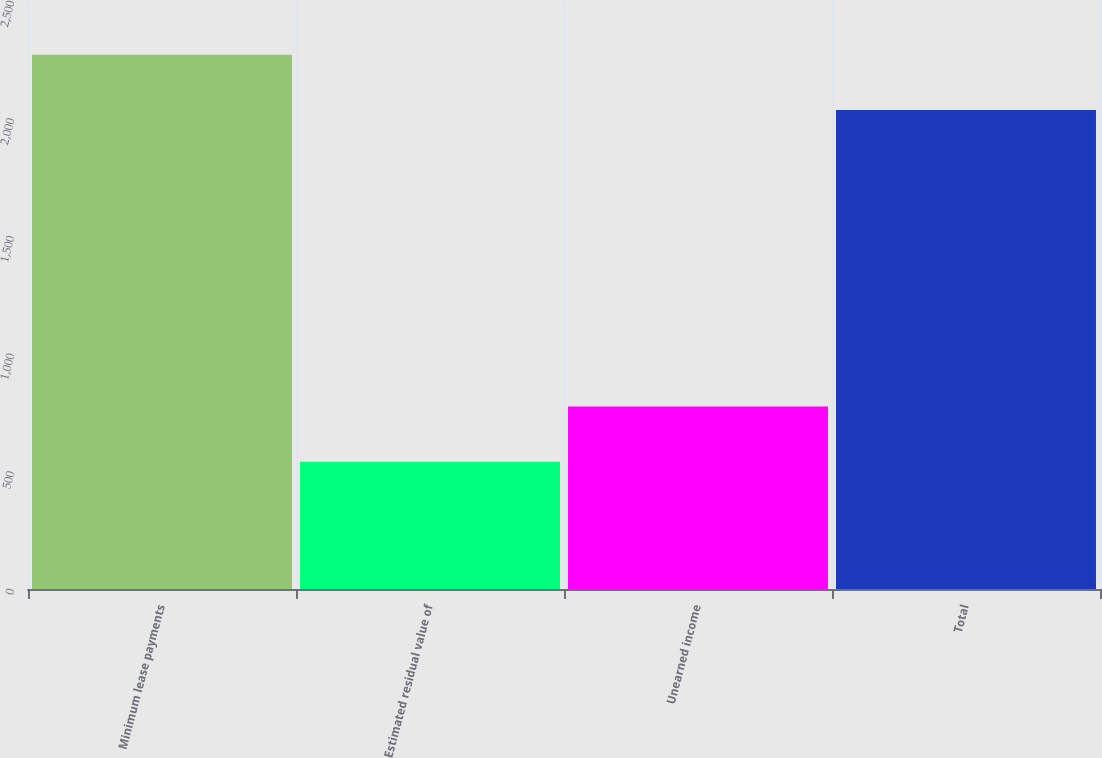Convert chart to OTSL. <chart><loc_0><loc_0><loc_500><loc_500><bar_chart><fcel>Minimum lease payments<fcel>Estimated residual value of<fcel>Unearned income<fcel>Total<nl><fcel>2272<fcel>541<fcel>776<fcel>2037<nl></chart> 